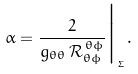<formula> <loc_0><loc_0><loc_500><loc_500>\alpha = \frac { 2 } { g _ { \theta \theta } \, \mathcal { R } _ { \theta \phi } ^ { \, \theta \phi } } \Big | _ { _ { \Sigma } } .</formula> 